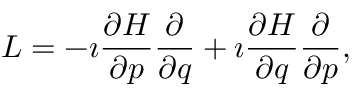Convert formula to latex. <formula><loc_0><loc_0><loc_500><loc_500>L = - \imath \frac { \partial H } { \partial p } \frac { \partial } { \partial q } + \imath \frac { \partial H } { \partial q } \frac { \partial } { \partial p } ,</formula> 